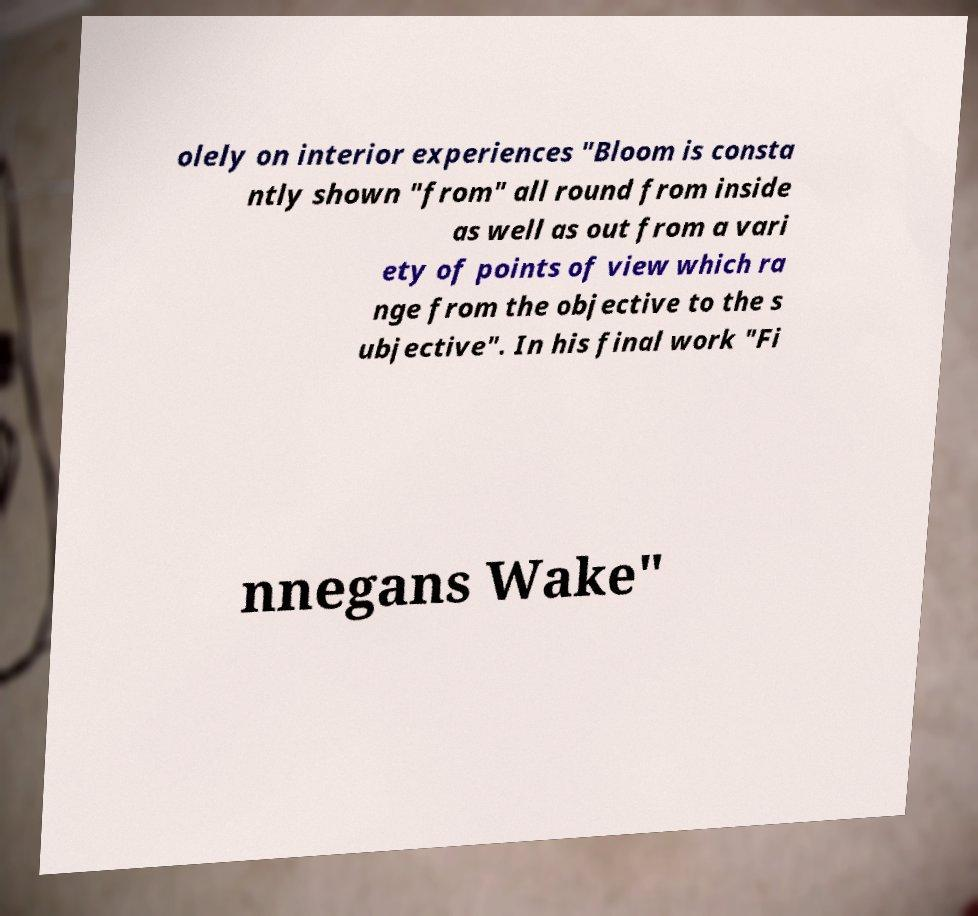Please read and relay the text visible in this image. What does it say? olely on interior experiences "Bloom is consta ntly shown "from" all round from inside as well as out from a vari ety of points of view which ra nge from the objective to the s ubjective". In his final work "Fi nnegans Wake" 